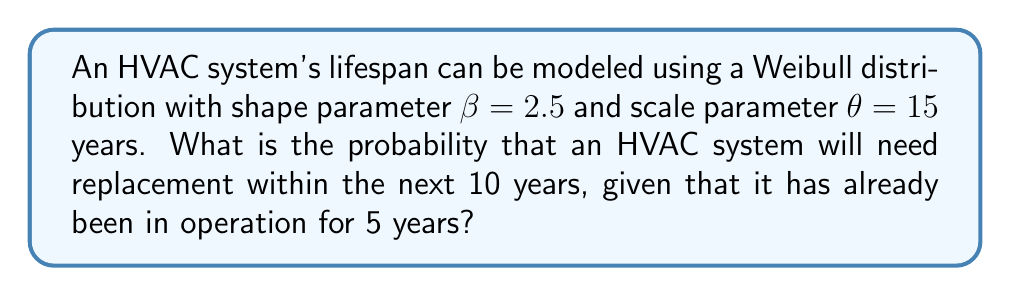What is the answer to this math problem? To solve this problem, we'll use the concept of conditional reliability in the Weibull distribution.

Step 1: The reliability function for a Weibull distribution is given by:
$$R(t) = e^{-(\frac{t}{\theta})^\beta}$$

Step 2: The conditional reliability function for a system that has already survived for time $t_1$ and operates for an additional time $t_2$ is:
$$R(t_2|t_1) = \frac{R(t_1 + t_2)}{R(t_1)}$$

Step 3: In our case, $t_1 = 5$ years and $t_2 = 10$ years. We need to calculate:
$$R(15|5) = \frac{R(15)}{R(5)}$$

Step 4: Calculate $R(5)$:
$$R(5) = e^{-(\frac{5}{15})^{2.5}} = e^{-0.0630} = 0.9389$$

Step 5: Calculate $R(15)$:
$$R(15) = e^{-(\frac{15}{15})^{2.5}} = e^{-1} = 0.3679$$

Step 6: Calculate the conditional reliability:
$$R(15|5) = \frac{0.3679}{0.9389} = 0.3918$$

Step 7: The probability of failure (needing replacement) within the next 10 years is:
$$P(\text{failure}) = 1 - R(15|5) = 1 - 0.3918 = 0.6082$$
Answer: 0.6082 or 60.82% 